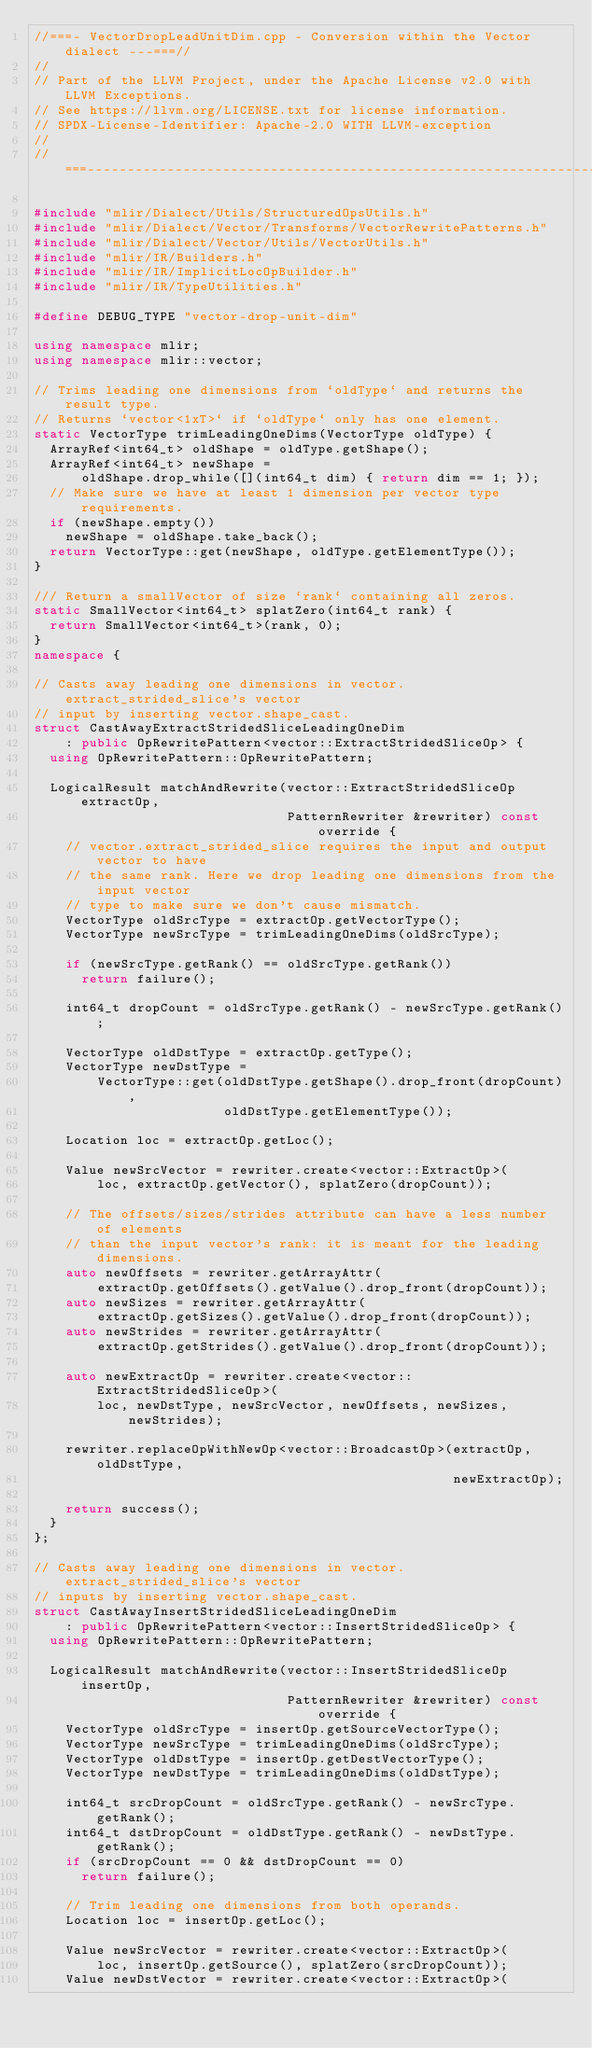Convert code to text. <code><loc_0><loc_0><loc_500><loc_500><_C++_>//===- VectorDropLeadUnitDim.cpp - Conversion within the Vector dialect ---===//
//
// Part of the LLVM Project, under the Apache License v2.0 with LLVM Exceptions.
// See https://llvm.org/LICENSE.txt for license information.
// SPDX-License-Identifier: Apache-2.0 WITH LLVM-exception
//
//===----------------------------------------------------------------------===//

#include "mlir/Dialect/Utils/StructuredOpsUtils.h"
#include "mlir/Dialect/Vector/Transforms/VectorRewritePatterns.h"
#include "mlir/Dialect/Vector/Utils/VectorUtils.h"
#include "mlir/IR/Builders.h"
#include "mlir/IR/ImplicitLocOpBuilder.h"
#include "mlir/IR/TypeUtilities.h"

#define DEBUG_TYPE "vector-drop-unit-dim"

using namespace mlir;
using namespace mlir::vector;

// Trims leading one dimensions from `oldType` and returns the result type.
// Returns `vector<1xT>` if `oldType` only has one element.
static VectorType trimLeadingOneDims(VectorType oldType) {
  ArrayRef<int64_t> oldShape = oldType.getShape();
  ArrayRef<int64_t> newShape =
      oldShape.drop_while([](int64_t dim) { return dim == 1; });
  // Make sure we have at least 1 dimension per vector type requirements.
  if (newShape.empty())
    newShape = oldShape.take_back();
  return VectorType::get(newShape, oldType.getElementType());
}

/// Return a smallVector of size `rank` containing all zeros.
static SmallVector<int64_t> splatZero(int64_t rank) {
  return SmallVector<int64_t>(rank, 0);
}
namespace {

// Casts away leading one dimensions in vector.extract_strided_slice's vector
// input by inserting vector.shape_cast.
struct CastAwayExtractStridedSliceLeadingOneDim
    : public OpRewritePattern<vector::ExtractStridedSliceOp> {
  using OpRewritePattern::OpRewritePattern;

  LogicalResult matchAndRewrite(vector::ExtractStridedSliceOp extractOp,
                                PatternRewriter &rewriter) const override {
    // vector.extract_strided_slice requires the input and output vector to have
    // the same rank. Here we drop leading one dimensions from the input vector
    // type to make sure we don't cause mismatch.
    VectorType oldSrcType = extractOp.getVectorType();
    VectorType newSrcType = trimLeadingOneDims(oldSrcType);

    if (newSrcType.getRank() == oldSrcType.getRank())
      return failure();

    int64_t dropCount = oldSrcType.getRank() - newSrcType.getRank();

    VectorType oldDstType = extractOp.getType();
    VectorType newDstType =
        VectorType::get(oldDstType.getShape().drop_front(dropCount),
                        oldDstType.getElementType());

    Location loc = extractOp.getLoc();

    Value newSrcVector = rewriter.create<vector::ExtractOp>(
        loc, extractOp.getVector(), splatZero(dropCount));

    // The offsets/sizes/strides attribute can have a less number of elements
    // than the input vector's rank: it is meant for the leading dimensions.
    auto newOffsets = rewriter.getArrayAttr(
        extractOp.getOffsets().getValue().drop_front(dropCount));
    auto newSizes = rewriter.getArrayAttr(
        extractOp.getSizes().getValue().drop_front(dropCount));
    auto newStrides = rewriter.getArrayAttr(
        extractOp.getStrides().getValue().drop_front(dropCount));

    auto newExtractOp = rewriter.create<vector::ExtractStridedSliceOp>(
        loc, newDstType, newSrcVector, newOffsets, newSizes, newStrides);

    rewriter.replaceOpWithNewOp<vector::BroadcastOp>(extractOp, oldDstType,
                                                     newExtractOp);

    return success();
  }
};

// Casts away leading one dimensions in vector.extract_strided_slice's vector
// inputs by inserting vector.shape_cast.
struct CastAwayInsertStridedSliceLeadingOneDim
    : public OpRewritePattern<vector::InsertStridedSliceOp> {
  using OpRewritePattern::OpRewritePattern;

  LogicalResult matchAndRewrite(vector::InsertStridedSliceOp insertOp,
                                PatternRewriter &rewriter) const override {
    VectorType oldSrcType = insertOp.getSourceVectorType();
    VectorType newSrcType = trimLeadingOneDims(oldSrcType);
    VectorType oldDstType = insertOp.getDestVectorType();
    VectorType newDstType = trimLeadingOneDims(oldDstType);

    int64_t srcDropCount = oldSrcType.getRank() - newSrcType.getRank();
    int64_t dstDropCount = oldDstType.getRank() - newDstType.getRank();
    if (srcDropCount == 0 && dstDropCount == 0)
      return failure();

    // Trim leading one dimensions from both operands.
    Location loc = insertOp.getLoc();

    Value newSrcVector = rewriter.create<vector::ExtractOp>(
        loc, insertOp.getSource(), splatZero(srcDropCount));
    Value newDstVector = rewriter.create<vector::ExtractOp>(</code> 